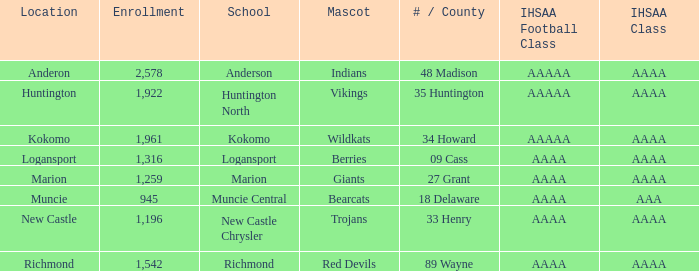What's the IHSAA class of the Red Devils? AAAA. 